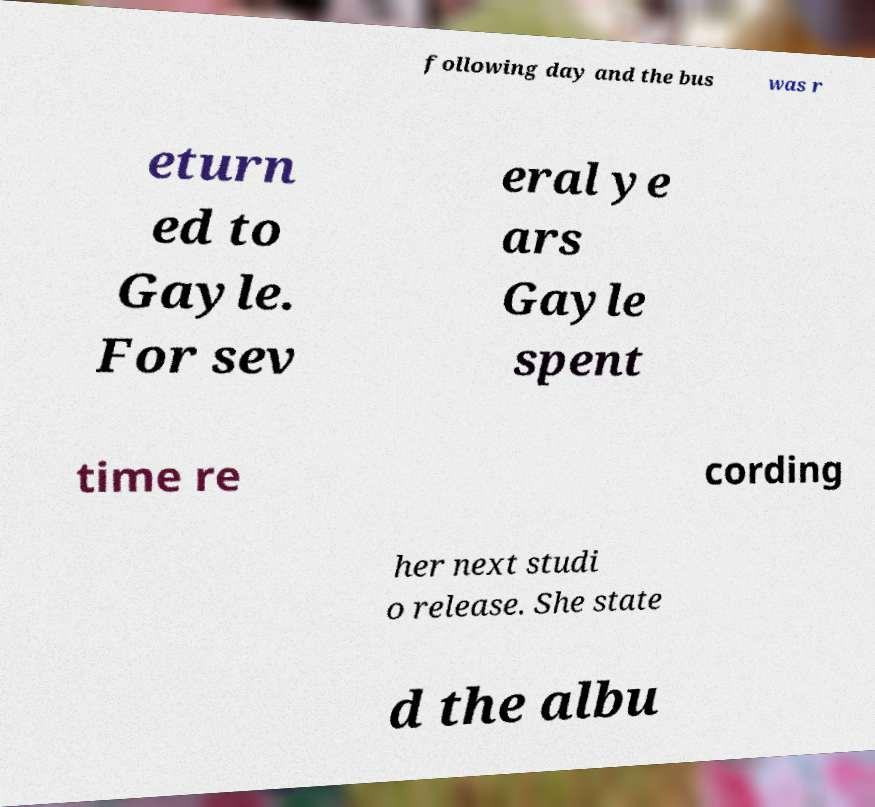Can you accurately transcribe the text from the provided image for me? following day and the bus was r eturn ed to Gayle. For sev eral ye ars Gayle spent time re cording her next studi o release. She state d the albu 